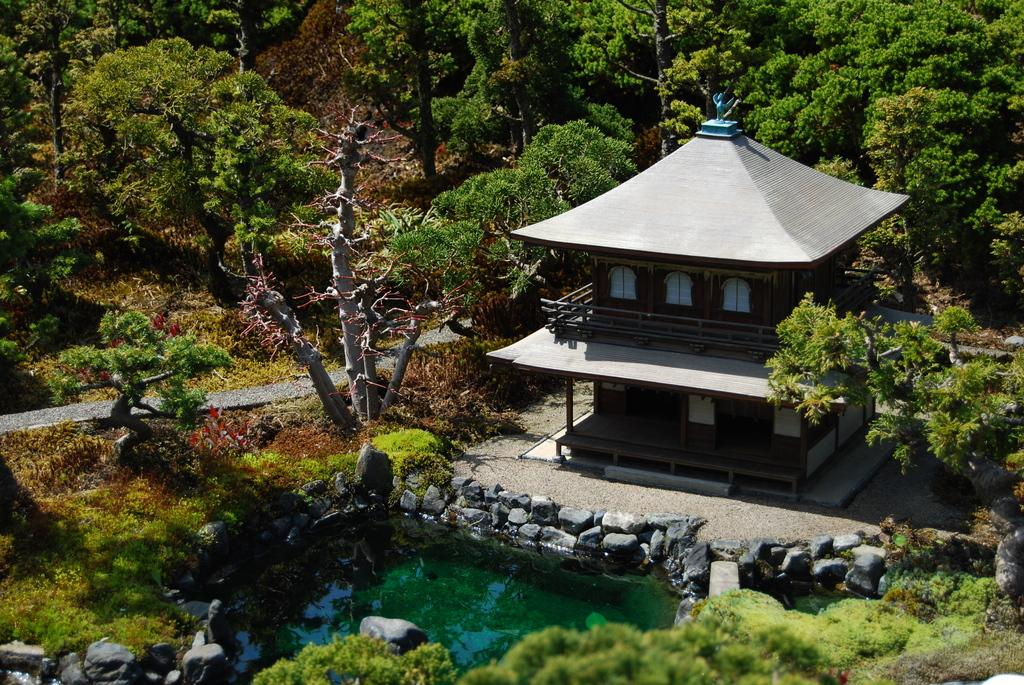What type of structure is visible in the image? There is a house in the image. What decorative element can be seen on the house? There is a sculpture on the house. What type of vegetation is present in the image? There are trees, grass, and water in the image. What type of surface is at the bottom of the image? There is a pavement at the bottom of the image. What type of natural material is present in the image? There are stones in the image. What type of hat is the water wearing in the image? There is no hat present in the image, as water is a liquid and does not wear clothing. 